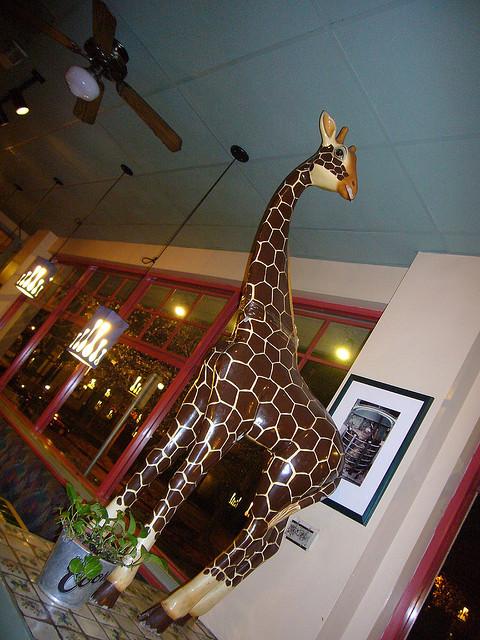Where might this giraffe be located?
Keep it brief. Museum. Is this giraffe real?
Write a very short answer. No. Is the giraffe real?
Give a very brief answer. No. 